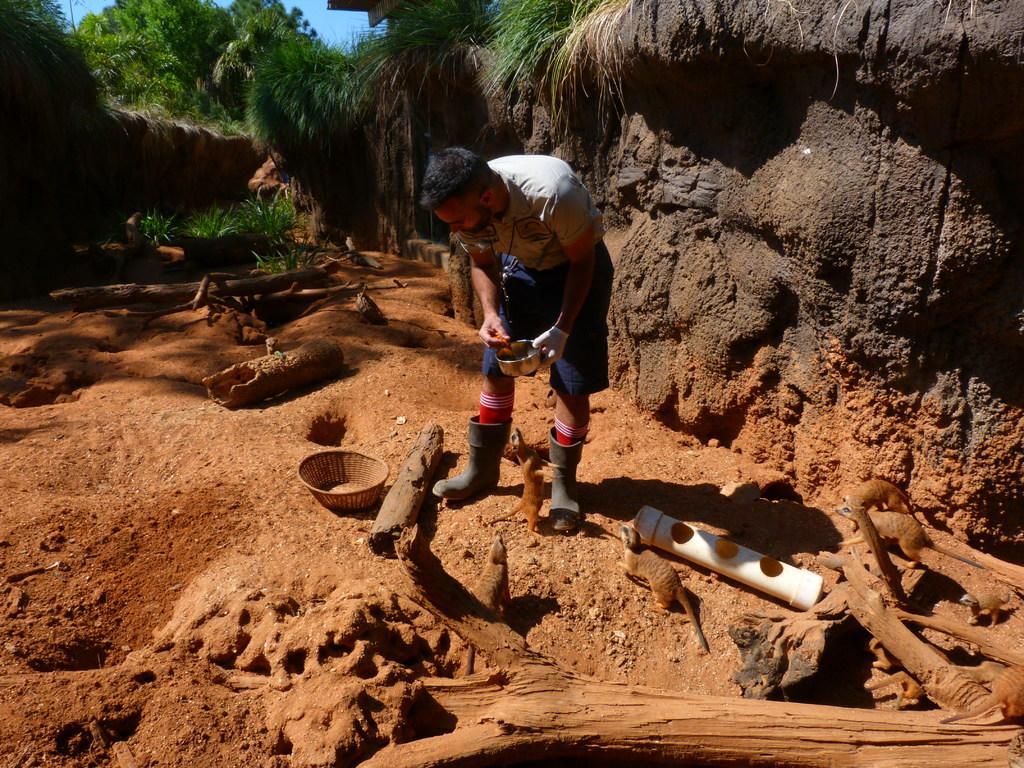Can you describe this image briefly? In the center of the image a man is standing and holding a vessel in his hand. On the right side of the image we can see a mud wall is there. At the top of the image we can see some trees, sky are there. In the middle of the image we can see some plants, container and some animals are there. At the bottom right corner wood sticks are present. In the background of the image mud is there. 